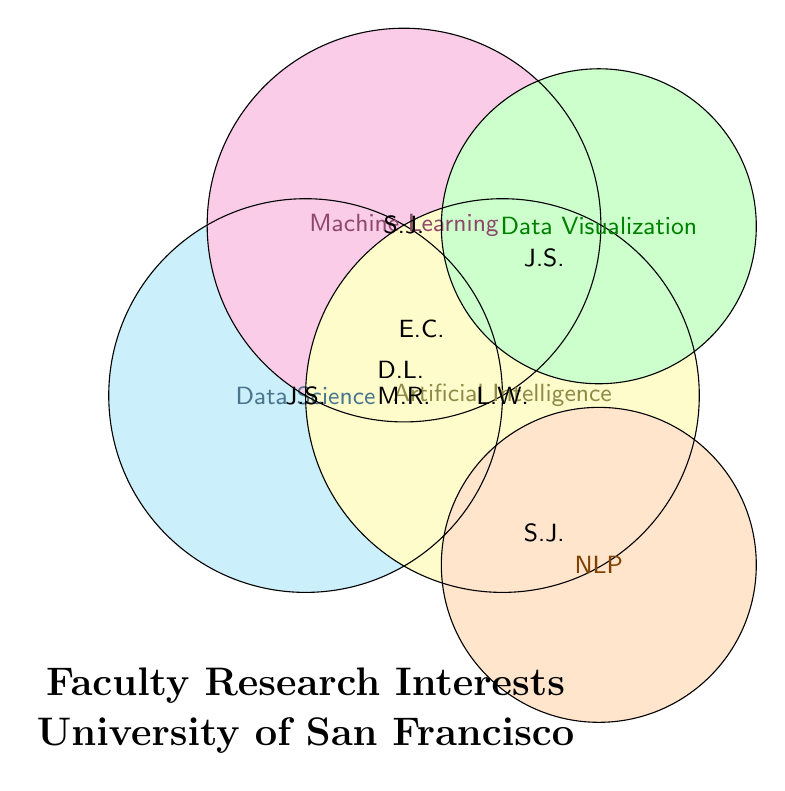Which faculty members are interested in Data Science? The section labeled "Data Science" is filled with a specific color, and it contains initials J.S., E.C., and M.R.
Answer: John Smith, Emily Chen, Michael Rodriguez Which research areas does Emily Chen work in? Emily Chen's initials (E.C.) appear in multiple sections of the diagram: "Data Science," "Machine Learning," and "Natural Language Processing."
Answer: Data Science, Machine Learning, Natural Language Processing How many faculty members are involved in Artificial Intelligence research? The section labeled "Artificial Intelligence" contains the initials M.R., D.L., and L.W., representing three faculty members.
Answer: 3 Which research interests do John Smith have? John Smith's initials (J.S.) appear in the sections for "Data Science" and "Data Visualization."
Answer: Data Science, Data Visualization Do any faculty members have an interest in both Machine Learning and Artificial Intelligence? The initials D.L. (David Lee) appear in both the "Machine Learning" and "Artificial Intelligence" sections.
Answer: Yes How many areas is Michael Rodriguez involved in? Michael Rodriguez's initials (M.R.) appear in the "Data Science" and "Artificial Intelligence" sections.
Answer: 2 Which faculty members work in Natural Language Processing? The section labeled "Natural Language Processing" contains initials S.J. and E.C.
Answer: Sarah Johnson, Emily Chen Is there a faculty member involved in all listed research areas? Check each section for a single faculty member's initials appearing across all circles. No initials appear in all sections.
Answer: No Which research areas do David Lee work in? David Lee's initials (D.L.) are found in "Machine Learning" and "Artificial Intelligence."
Answer: Machine Learning, Artificial Intelligence Who shares research interests in Machine Learning and Data Science? Emily Chen (E.C.) appears in both "Machine Learning" and "Data Science" sections.
Answer: Emily Chen 